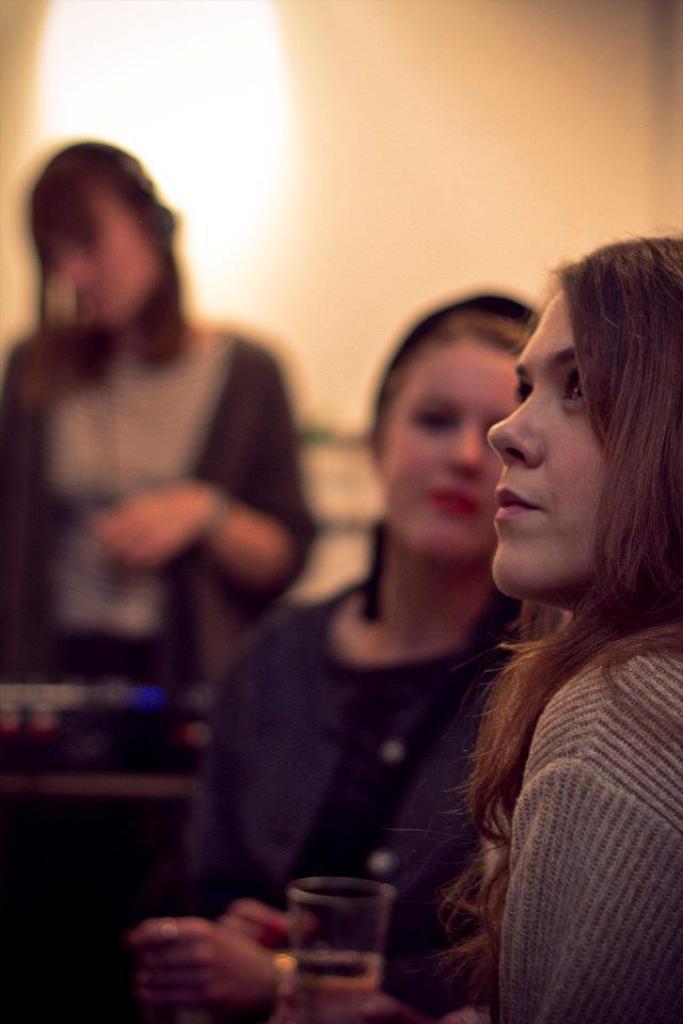Please provide a concise description of this image. In this image there is a girl on the right side. Behind the girl there is another girl sitting in the chair. There is a glass in front of her. In the background there is a girl standing near the sound system. At the top there is light. 